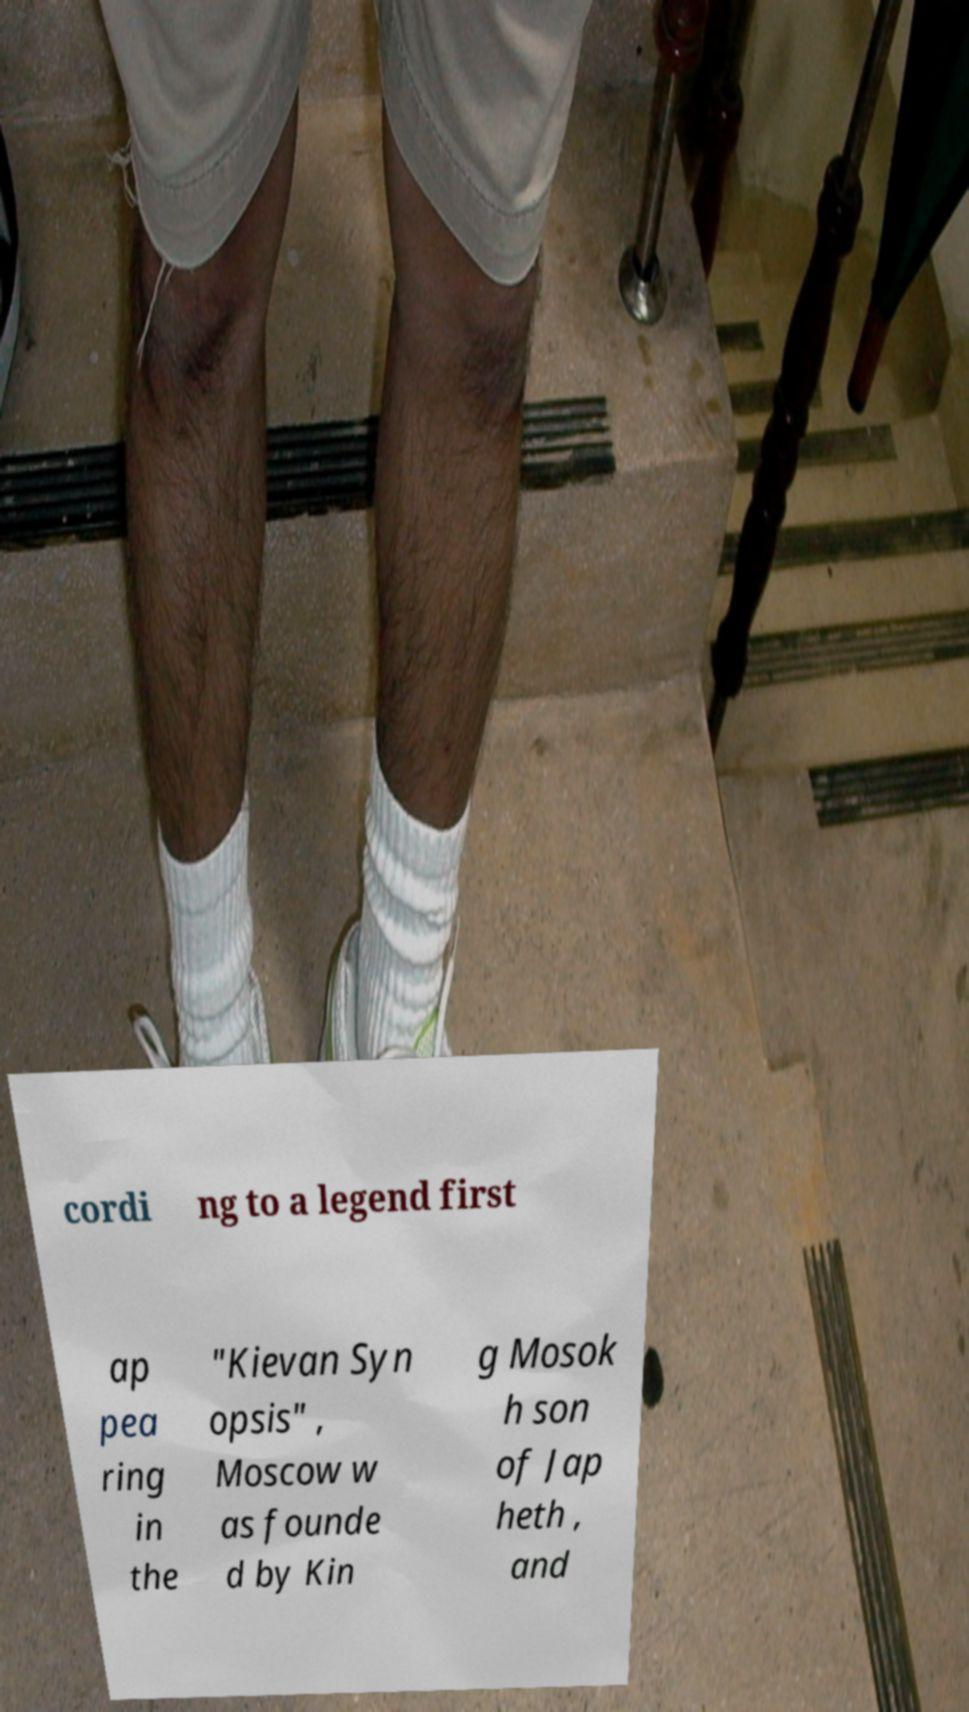There's text embedded in this image that I need extracted. Can you transcribe it verbatim? cordi ng to a legend first ap pea ring in the "Kievan Syn opsis" , Moscow w as founde d by Kin g Mosok h son of Jap heth , and 